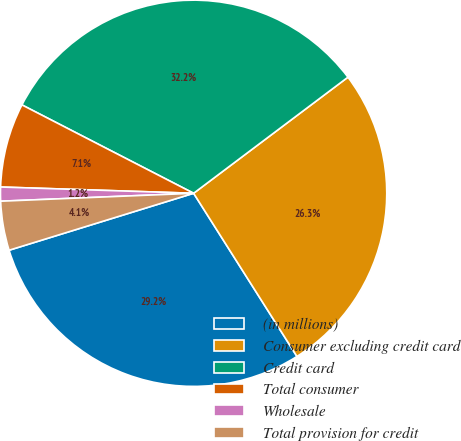Convert chart. <chart><loc_0><loc_0><loc_500><loc_500><pie_chart><fcel>(in millions)<fcel>Consumer excluding credit card<fcel>Credit card<fcel>Total consumer<fcel>Wholesale<fcel>Total provision for credit<nl><fcel>29.22%<fcel>26.28%<fcel>32.17%<fcel>7.05%<fcel>1.17%<fcel>4.11%<nl></chart> 